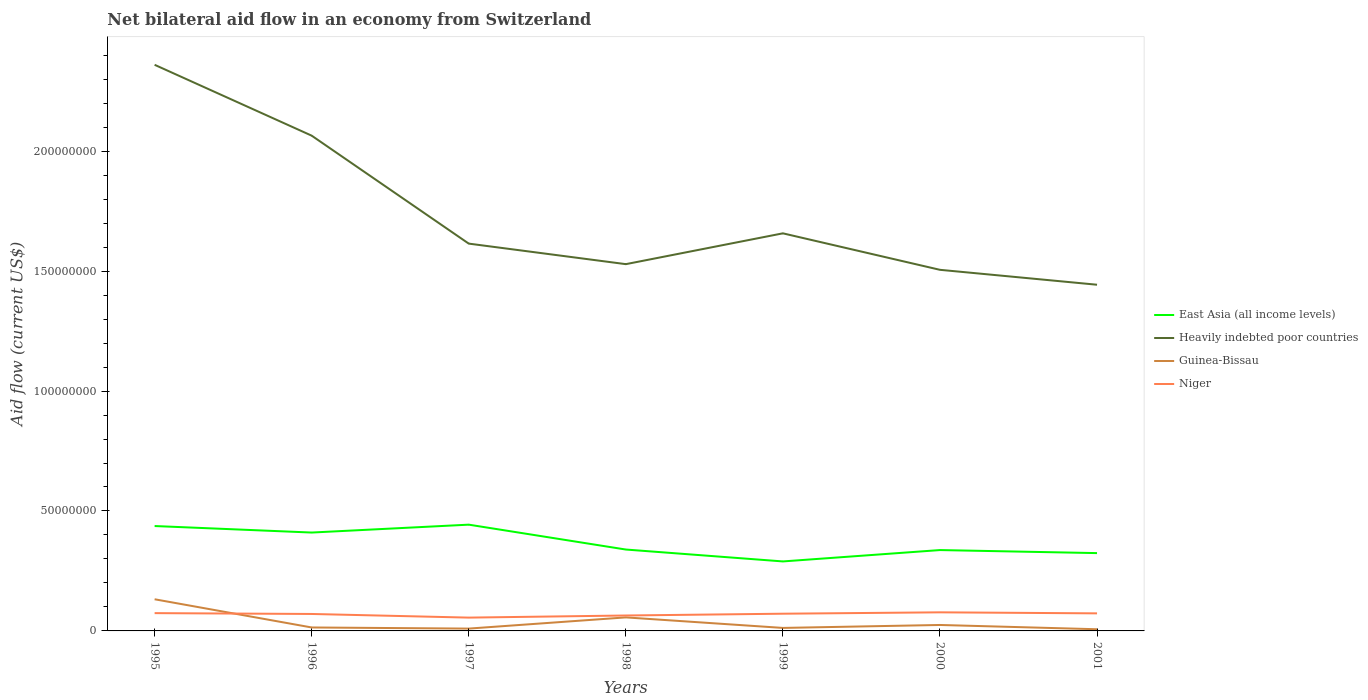Across all years, what is the maximum net bilateral aid flow in East Asia (all income levels)?
Provide a succinct answer. 2.90e+07. In which year was the net bilateral aid flow in Heavily indebted poor countries maximum?
Provide a short and direct response. 2001. What is the total net bilateral aid flow in East Asia (all income levels) in the graph?
Provide a short and direct response. -4.74e+06. What is the difference between the highest and the second highest net bilateral aid flow in Niger?
Offer a very short reply. 2.20e+06. Is the net bilateral aid flow in Heavily indebted poor countries strictly greater than the net bilateral aid flow in East Asia (all income levels) over the years?
Provide a succinct answer. No. How many lines are there?
Offer a very short reply. 4. How many years are there in the graph?
Give a very brief answer. 7. What is the difference between two consecutive major ticks on the Y-axis?
Your answer should be compact. 5.00e+07. Does the graph contain any zero values?
Make the answer very short. No. What is the title of the graph?
Make the answer very short. Net bilateral aid flow in an economy from Switzerland. What is the Aid flow (current US$) of East Asia (all income levels) in 1995?
Your response must be concise. 4.37e+07. What is the Aid flow (current US$) in Heavily indebted poor countries in 1995?
Your response must be concise. 2.36e+08. What is the Aid flow (current US$) of Guinea-Bissau in 1995?
Your answer should be very brief. 1.32e+07. What is the Aid flow (current US$) of Niger in 1995?
Offer a very short reply. 7.42e+06. What is the Aid flow (current US$) of East Asia (all income levels) in 1996?
Provide a short and direct response. 4.10e+07. What is the Aid flow (current US$) of Heavily indebted poor countries in 1996?
Your answer should be very brief. 2.06e+08. What is the Aid flow (current US$) of Guinea-Bissau in 1996?
Your response must be concise. 1.44e+06. What is the Aid flow (current US$) of Niger in 1996?
Provide a short and direct response. 7.07e+06. What is the Aid flow (current US$) of East Asia (all income levels) in 1997?
Give a very brief answer. 4.43e+07. What is the Aid flow (current US$) in Heavily indebted poor countries in 1997?
Keep it short and to the point. 1.61e+08. What is the Aid flow (current US$) of Guinea-Bissau in 1997?
Your response must be concise. 9.70e+05. What is the Aid flow (current US$) in Niger in 1997?
Offer a terse response. 5.55e+06. What is the Aid flow (current US$) in East Asia (all income levels) in 1998?
Give a very brief answer. 3.39e+07. What is the Aid flow (current US$) in Heavily indebted poor countries in 1998?
Your answer should be very brief. 1.53e+08. What is the Aid flow (current US$) of Guinea-Bissau in 1998?
Your answer should be compact. 5.64e+06. What is the Aid flow (current US$) in Niger in 1998?
Ensure brevity in your answer.  6.43e+06. What is the Aid flow (current US$) in East Asia (all income levels) in 1999?
Provide a short and direct response. 2.90e+07. What is the Aid flow (current US$) in Heavily indebted poor countries in 1999?
Make the answer very short. 1.66e+08. What is the Aid flow (current US$) of Guinea-Bissau in 1999?
Give a very brief answer. 1.25e+06. What is the Aid flow (current US$) of Niger in 1999?
Provide a short and direct response. 7.18e+06. What is the Aid flow (current US$) in East Asia (all income levels) in 2000?
Make the answer very short. 3.37e+07. What is the Aid flow (current US$) in Heavily indebted poor countries in 2000?
Make the answer very short. 1.51e+08. What is the Aid flow (current US$) in Guinea-Bissau in 2000?
Give a very brief answer. 2.48e+06. What is the Aid flow (current US$) in Niger in 2000?
Your answer should be very brief. 7.75e+06. What is the Aid flow (current US$) of East Asia (all income levels) in 2001?
Provide a succinct answer. 3.24e+07. What is the Aid flow (current US$) of Heavily indebted poor countries in 2001?
Your answer should be compact. 1.44e+08. What is the Aid flow (current US$) of Niger in 2001?
Your response must be concise. 7.32e+06. Across all years, what is the maximum Aid flow (current US$) of East Asia (all income levels)?
Your answer should be very brief. 4.43e+07. Across all years, what is the maximum Aid flow (current US$) of Heavily indebted poor countries?
Keep it short and to the point. 2.36e+08. Across all years, what is the maximum Aid flow (current US$) of Guinea-Bissau?
Ensure brevity in your answer.  1.32e+07. Across all years, what is the maximum Aid flow (current US$) in Niger?
Provide a succinct answer. 7.75e+06. Across all years, what is the minimum Aid flow (current US$) in East Asia (all income levels)?
Give a very brief answer. 2.90e+07. Across all years, what is the minimum Aid flow (current US$) in Heavily indebted poor countries?
Keep it short and to the point. 1.44e+08. Across all years, what is the minimum Aid flow (current US$) of Guinea-Bissau?
Your answer should be compact. 7.00e+05. Across all years, what is the minimum Aid flow (current US$) in Niger?
Ensure brevity in your answer.  5.55e+06. What is the total Aid flow (current US$) of East Asia (all income levels) in the graph?
Offer a terse response. 2.58e+08. What is the total Aid flow (current US$) in Heavily indebted poor countries in the graph?
Make the answer very short. 1.22e+09. What is the total Aid flow (current US$) of Guinea-Bissau in the graph?
Ensure brevity in your answer.  2.57e+07. What is the total Aid flow (current US$) in Niger in the graph?
Make the answer very short. 4.87e+07. What is the difference between the Aid flow (current US$) of East Asia (all income levels) in 1995 and that in 1996?
Provide a succinct answer. 2.72e+06. What is the difference between the Aid flow (current US$) in Heavily indebted poor countries in 1995 and that in 1996?
Your answer should be compact. 2.95e+07. What is the difference between the Aid flow (current US$) in Guinea-Bissau in 1995 and that in 1996?
Your answer should be compact. 1.18e+07. What is the difference between the Aid flow (current US$) in Niger in 1995 and that in 1996?
Make the answer very short. 3.50e+05. What is the difference between the Aid flow (current US$) in East Asia (all income levels) in 1995 and that in 1997?
Provide a succinct answer. -5.70e+05. What is the difference between the Aid flow (current US$) of Heavily indebted poor countries in 1995 and that in 1997?
Your answer should be compact. 7.46e+07. What is the difference between the Aid flow (current US$) in Guinea-Bissau in 1995 and that in 1997?
Offer a terse response. 1.22e+07. What is the difference between the Aid flow (current US$) of Niger in 1995 and that in 1997?
Ensure brevity in your answer.  1.87e+06. What is the difference between the Aid flow (current US$) of East Asia (all income levels) in 1995 and that in 1998?
Make the answer very short. 9.80e+06. What is the difference between the Aid flow (current US$) in Heavily indebted poor countries in 1995 and that in 1998?
Offer a terse response. 8.31e+07. What is the difference between the Aid flow (current US$) of Guinea-Bissau in 1995 and that in 1998?
Ensure brevity in your answer.  7.56e+06. What is the difference between the Aid flow (current US$) in Niger in 1995 and that in 1998?
Provide a succinct answer. 9.90e+05. What is the difference between the Aid flow (current US$) in East Asia (all income levels) in 1995 and that in 1999?
Your answer should be very brief. 1.48e+07. What is the difference between the Aid flow (current US$) of Heavily indebted poor countries in 1995 and that in 1999?
Give a very brief answer. 7.03e+07. What is the difference between the Aid flow (current US$) of Guinea-Bissau in 1995 and that in 1999?
Give a very brief answer. 1.20e+07. What is the difference between the Aid flow (current US$) in East Asia (all income levels) in 1995 and that in 2000?
Give a very brief answer. 1.00e+07. What is the difference between the Aid flow (current US$) in Heavily indebted poor countries in 1995 and that in 2000?
Offer a terse response. 8.55e+07. What is the difference between the Aid flow (current US$) in Guinea-Bissau in 1995 and that in 2000?
Offer a terse response. 1.07e+07. What is the difference between the Aid flow (current US$) in Niger in 1995 and that in 2000?
Your answer should be very brief. -3.30e+05. What is the difference between the Aid flow (current US$) in East Asia (all income levels) in 1995 and that in 2001?
Offer a very short reply. 1.13e+07. What is the difference between the Aid flow (current US$) of Heavily indebted poor countries in 1995 and that in 2001?
Your answer should be very brief. 9.17e+07. What is the difference between the Aid flow (current US$) of Guinea-Bissau in 1995 and that in 2001?
Give a very brief answer. 1.25e+07. What is the difference between the Aid flow (current US$) in Niger in 1995 and that in 2001?
Provide a short and direct response. 1.00e+05. What is the difference between the Aid flow (current US$) in East Asia (all income levels) in 1996 and that in 1997?
Your answer should be compact. -3.29e+06. What is the difference between the Aid flow (current US$) of Heavily indebted poor countries in 1996 and that in 1997?
Your answer should be compact. 4.50e+07. What is the difference between the Aid flow (current US$) of Niger in 1996 and that in 1997?
Your answer should be compact. 1.52e+06. What is the difference between the Aid flow (current US$) of East Asia (all income levels) in 1996 and that in 1998?
Provide a short and direct response. 7.08e+06. What is the difference between the Aid flow (current US$) of Heavily indebted poor countries in 1996 and that in 1998?
Give a very brief answer. 5.36e+07. What is the difference between the Aid flow (current US$) of Guinea-Bissau in 1996 and that in 1998?
Provide a short and direct response. -4.20e+06. What is the difference between the Aid flow (current US$) in Niger in 1996 and that in 1998?
Your response must be concise. 6.40e+05. What is the difference between the Aid flow (current US$) of East Asia (all income levels) in 1996 and that in 1999?
Offer a terse response. 1.20e+07. What is the difference between the Aid flow (current US$) in Heavily indebted poor countries in 1996 and that in 1999?
Offer a terse response. 4.07e+07. What is the difference between the Aid flow (current US$) of Guinea-Bissau in 1996 and that in 1999?
Your response must be concise. 1.90e+05. What is the difference between the Aid flow (current US$) of East Asia (all income levels) in 1996 and that in 2000?
Offer a very short reply. 7.30e+06. What is the difference between the Aid flow (current US$) in Heavily indebted poor countries in 1996 and that in 2000?
Make the answer very short. 5.59e+07. What is the difference between the Aid flow (current US$) of Guinea-Bissau in 1996 and that in 2000?
Keep it short and to the point. -1.04e+06. What is the difference between the Aid flow (current US$) of Niger in 1996 and that in 2000?
Ensure brevity in your answer.  -6.80e+05. What is the difference between the Aid flow (current US$) of East Asia (all income levels) in 1996 and that in 2001?
Offer a terse response. 8.57e+06. What is the difference between the Aid flow (current US$) in Heavily indebted poor countries in 1996 and that in 2001?
Your answer should be very brief. 6.22e+07. What is the difference between the Aid flow (current US$) of Guinea-Bissau in 1996 and that in 2001?
Your answer should be very brief. 7.40e+05. What is the difference between the Aid flow (current US$) in East Asia (all income levels) in 1997 and that in 1998?
Ensure brevity in your answer.  1.04e+07. What is the difference between the Aid flow (current US$) of Heavily indebted poor countries in 1997 and that in 1998?
Ensure brevity in your answer.  8.56e+06. What is the difference between the Aid flow (current US$) in Guinea-Bissau in 1997 and that in 1998?
Ensure brevity in your answer.  -4.67e+06. What is the difference between the Aid flow (current US$) of Niger in 1997 and that in 1998?
Provide a succinct answer. -8.80e+05. What is the difference between the Aid flow (current US$) of East Asia (all income levels) in 1997 and that in 1999?
Offer a very short reply. 1.53e+07. What is the difference between the Aid flow (current US$) of Heavily indebted poor countries in 1997 and that in 1999?
Give a very brief answer. -4.29e+06. What is the difference between the Aid flow (current US$) of Guinea-Bissau in 1997 and that in 1999?
Offer a very short reply. -2.80e+05. What is the difference between the Aid flow (current US$) of Niger in 1997 and that in 1999?
Your answer should be compact. -1.63e+06. What is the difference between the Aid flow (current US$) of East Asia (all income levels) in 1997 and that in 2000?
Provide a succinct answer. 1.06e+07. What is the difference between the Aid flow (current US$) of Heavily indebted poor countries in 1997 and that in 2000?
Your answer should be compact. 1.09e+07. What is the difference between the Aid flow (current US$) in Guinea-Bissau in 1997 and that in 2000?
Keep it short and to the point. -1.51e+06. What is the difference between the Aid flow (current US$) in Niger in 1997 and that in 2000?
Give a very brief answer. -2.20e+06. What is the difference between the Aid flow (current US$) in East Asia (all income levels) in 1997 and that in 2001?
Offer a terse response. 1.19e+07. What is the difference between the Aid flow (current US$) of Heavily indebted poor countries in 1997 and that in 2001?
Offer a terse response. 1.71e+07. What is the difference between the Aid flow (current US$) of Niger in 1997 and that in 2001?
Ensure brevity in your answer.  -1.77e+06. What is the difference between the Aid flow (current US$) of East Asia (all income levels) in 1998 and that in 1999?
Make the answer very short. 4.96e+06. What is the difference between the Aid flow (current US$) in Heavily indebted poor countries in 1998 and that in 1999?
Offer a very short reply. -1.28e+07. What is the difference between the Aid flow (current US$) of Guinea-Bissau in 1998 and that in 1999?
Offer a terse response. 4.39e+06. What is the difference between the Aid flow (current US$) of Niger in 1998 and that in 1999?
Keep it short and to the point. -7.50e+05. What is the difference between the Aid flow (current US$) of East Asia (all income levels) in 1998 and that in 2000?
Your response must be concise. 2.20e+05. What is the difference between the Aid flow (current US$) in Heavily indebted poor countries in 1998 and that in 2000?
Make the answer very short. 2.36e+06. What is the difference between the Aid flow (current US$) of Guinea-Bissau in 1998 and that in 2000?
Your answer should be compact. 3.16e+06. What is the difference between the Aid flow (current US$) in Niger in 1998 and that in 2000?
Provide a succinct answer. -1.32e+06. What is the difference between the Aid flow (current US$) in East Asia (all income levels) in 1998 and that in 2001?
Keep it short and to the point. 1.49e+06. What is the difference between the Aid flow (current US$) in Heavily indebted poor countries in 1998 and that in 2001?
Your answer should be compact. 8.58e+06. What is the difference between the Aid flow (current US$) of Guinea-Bissau in 1998 and that in 2001?
Make the answer very short. 4.94e+06. What is the difference between the Aid flow (current US$) in Niger in 1998 and that in 2001?
Offer a very short reply. -8.90e+05. What is the difference between the Aid flow (current US$) of East Asia (all income levels) in 1999 and that in 2000?
Provide a short and direct response. -4.74e+06. What is the difference between the Aid flow (current US$) in Heavily indebted poor countries in 1999 and that in 2000?
Your answer should be compact. 1.52e+07. What is the difference between the Aid flow (current US$) of Guinea-Bissau in 1999 and that in 2000?
Your answer should be compact. -1.23e+06. What is the difference between the Aid flow (current US$) in Niger in 1999 and that in 2000?
Make the answer very short. -5.70e+05. What is the difference between the Aid flow (current US$) of East Asia (all income levels) in 1999 and that in 2001?
Your answer should be compact. -3.47e+06. What is the difference between the Aid flow (current US$) in Heavily indebted poor countries in 1999 and that in 2001?
Give a very brief answer. 2.14e+07. What is the difference between the Aid flow (current US$) of Guinea-Bissau in 1999 and that in 2001?
Ensure brevity in your answer.  5.50e+05. What is the difference between the Aid flow (current US$) of Niger in 1999 and that in 2001?
Make the answer very short. -1.40e+05. What is the difference between the Aid flow (current US$) in East Asia (all income levels) in 2000 and that in 2001?
Offer a terse response. 1.27e+06. What is the difference between the Aid flow (current US$) of Heavily indebted poor countries in 2000 and that in 2001?
Keep it short and to the point. 6.22e+06. What is the difference between the Aid flow (current US$) of Guinea-Bissau in 2000 and that in 2001?
Provide a short and direct response. 1.78e+06. What is the difference between the Aid flow (current US$) of East Asia (all income levels) in 1995 and the Aid flow (current US$) of Heavily indebted poor countries in 1996?
Offer a terse response. -1.63e+08. What is the difference between the Aid flow (current US$) in East Asia (all income levels) in 1995 and the Aid flow (current US$) in Guinea-Bissau in 1996?
Offer a terse response. 4.23e+07. What is the difference between the Aid flow (current US$) in East Asia (all income levels) in 1995 and the Aid flow (current US$) in Niger in 1996?
Provide a short and direct response. 3.67e+07. What is the difference between the Aid flow (current US$) of Heavily indebted poor countries in 1995 and the Aid flow (current US$) of Guinea-Bissau in 1996?
Your answer should be very brief. 2.35e+08. What is the difference between the Aid flow (current US$) of Heavily indebted poor countries in 1995 and the Aid flow (current US$) of Niger in 1996?
Offer a very short reply. 2.29e+08. What is the difference between the Aid flow (current US$) in Guinea-Bissau in 1995 and the Aid flow (current US$) in Niger in 1996?
Ensure brevity in your answer.  6.13e+06. What is the difference between the Aid flow (current US$) in East Asia (all income levels) in 1995 and the Aid flow (current US$) in Heavily indebted poor countries in 1997?
Your response must be concise. -1.18e+08. What is the difference between the Aid flow (current US$) of East Asia (all income levels) in 1995 and the Aid flow (current US$) of Guinea-Bissau in 1997?
Offer a terse response. 4.28e+07. What is the difference between the Aid flow (current US$) in East Asia (all income levels) in 1995 and the Aid flow (current US$) in Niger in 1997?
Keep it short and to the point. 3.82e+07. What is the difference between the Aid flow (current US$) of Heavily indebted poor countries in 1995 and the Aid flow (current US$) of Guinea-Bissau in 1997?
Offer a terse response. 2.35e+08. What is the difference between the Aid flow (current US$) of Heavily indebted poor countries in 1995 and the Aid flow (current US$) of Niger in 1997?
Provide a succinct answer. 2.30e+08. What is the difference between the Aid flow (current US$) in Guinea-Bissau in 1995 and the Aid flow (current US$) in Niger in 1997?
Keep it short and to the point. 7.65e+06. What is the difference between the Aid flow (current US$) of East Asia (all income levels) in 1995 and the Aid flow (current US$) of Heavily indebted poor countries in 1998?
Keep it short and to the point. -1.09e+08. What is the difference between the Aid flow (current US$) in East Asia (all income levels) in 1995 and the Aid flow (current US$) in Guinea-Bissau in 1998?
Ensure brevity in your answer.  3.81e+07. What is the difference between the Aid flow (current US$) of East Asia (all income levels) in 1995 and the Aid flow (current US$) of Niger in 1998?
Give a very brief answer. 3.73e+07. What is the difference between the Aid flow (current US$) in Heavily indebted poor countries in 1995 and the Aid flow (current US$) in Guinea-Bissau in 1998?
Your response must be concise. 2.30e+08. What is the difference between the Aid flow (current US$) in Heavily indebted poor countries in 1995 and the Aid flow (current US$) in Niger in 1998?
Your response must be concise. 2.30e+08. What is the difference between the Aid flow (current US$) in Guinea-Bissau in 1995 and the Aid flow (current US$) in Niger in 1998?
Give a very brief answer. 6.77e+06. What is the difference between the Aid flow (current US$) of East Asia (all income levels) in 1995 and the Aid flow (current US$) of Heavily indebted poor countries in 1999?
Make the answer very short. -1.22e+08. What is the difference between the Aid flow (current US$) of East Asia (all income levels) in 1995 and the Aid flow (current US$) of Guinea-Bissau in 1999?
Keep it short and to the point. 4.25e+07. What is the difference between the Aid flow (current US$) of East Asia (all income levels) in 1995 and the Aid flow (current US$) of Niger in 1999?
Keep it short and to the point. 3.66e+07. What is the difference between the Aid flow (current US$) of Heavily indebted poor countries in 1995 and the Aid flow (current US$) of Guinea-Bissau in 1999?
Ensure brevity in your answer.  2.35e+08. What is the difference between the Aid flow (current US$) in Heavily indebted poor countries in 1995 and the Aid flow (current US$) in Niger in 1999?
Make the answer very short. 2.29e+08. What is the difference between the Aid flow (current US$) of Guinea-Bissau in 1995 and the Aid flow (current US$) of Niger in 1999?
Offer a terse response. 6.02e+06. What is the difference between the Aid flow (current US$) of East Asia (all income levels) in 1995 and the Aid flow (current US$) of Heavily indebted poor countries in 2000?
Your answer should be very brief. -1.07e+08. What is the difference between the Aid flow (current US$) of East Asia (all income levels) in 1995 and the Aid flow (current US$) of Guinea-Bissau in 2000?
Your answer should be very brief. 4.12e+07. What is the difference between the Aid flow (current US$) of East Asia (all income levels) in 1995 and the Aid flow (current US$) of Niger in 2000?
Keep it short and to the point. 3.60e+07. What is the difference between the Aid flow (current US$) in Heavily indebted poor countries in 1995 and the Aid flow (current US$) in Guinea-Bissau in 2000?
Your answer should be very brief. 2.34e+08. What is the difference between the Aid flow (current US$) in Heavily indebted poor countries in 1995 and the Aid flow (current US$) in Niger in 2000?
Provide a succinct answer. 2.28e+08. What is the difference between the Aid flow (current US$) of Guinea-Bissau in 1995 and the Aid flow (current US$) of Niger in 2000?
Ensure brevity in your answer.  5.45e+06. What is the difference between the Aid flow (current US$) of East Asia (all income levels) in 1995 and the Aid flow (current US$) of Heavily indebted poor countries in 2001?
Provide a succinct answer. -1.01e+08. What is the difference between the Aid flow (current US$) of East Asia (all income levels) in 1995 and the Aid flow (current US$) of Guinea-Bissau in 2001?
Ensure brevity in your answer.  4.30e+07. What is the difference between the Aid flow (current US$) in East Asia (all income levels) in 1995 and the Aid flow (current US$) in Niger in 2001?
Your answer should be very brief. 3.64e+07. What is the difference between the Aid flow (current US$) in Heavily indebted poor countries in 1995 and the Aid flow (current US$) in Guinea-Bissau in 2001?
Your answer should be very brief. 2.35e+08. What is the difference between the Aid flow (current US$) of Heavily indebted poor countries in 1995 and the Aid flow (current US$) of Niger in 2001?
Your answer should be very brief. 2.29e+08. What is the difference between the Aid flow (current US$) in Guinea-Bissau in 1995 and the Aid flow (current US$) in Niger in 2001?
Your answer should be compact. 5.88e+06. What is the difference between the Aid flow (current US$) of East Asia (all income levels) in 1996 and the Aid flow (current US$) of Heavily indebted poor countries in 1997?
Offer a very short reply. -1.20e+08. What is the difference between the Aid flow (current US$) in East Asia (all income levels) in 1996 and the Aid flow (current US$) in Guinea-Bissau in 1997?
Give a very brief answer. 4.00e+07. What is the difference between the Aid flow (current US$) in East Asia (all income levels) in 1996 and the Aid flow (current US$) in Niger in 1997?
Offer a terse response. 3.55e+07. What is the difference between the Aid flow (current US$) of Heavily indebted poor countries in 1996 and the Aid flow (current US$) of Guinea-Bissau in 1997?
Ensure brevity in your answer.  2.06e+08. What is the difference between the Aid flow (current US$) in Heavily indebted poor countries in 1996 and the Aid flow (current US$) in Niger in 1997?
Provide a succinct answer. 2.01e+08. What is the difference between the Aid flow (current US$) of Guinea-Bissau in 1996 and the Aid flow (current US$) of Niger in 1997?
Ensure brevity in your answer.  -4.11e+06. What is the difference between the Aid flow (current US$) in East Asia (all income levels) in 1996 and the Aid flow (current US$) in Heavily indebted poor countries in 1998?
Ensure brevity in your answer.  -1.12e+08. What is the difference between the Aid flow (current US$) in East Asia (all income levels) in 1996 and the Aid flow (current US$) in Guinea-Bissau in 1998?
Your answer should be compact. 3.54e+07. What is the difference between the Aid flow (current US$) in East Asia (all income levels) in 1996 and the Aid flow (current US$) in Niger in 1998?
Your answer should be very brief. 3.46e+07. What is the difference between the Aid flow (current US$) of Heavily indebted poor countries in 1996 and the Aid flow (current US$) of Guinea-Bissau in 1998?
Your answer should be very brief. 2.01e+08. What is the difference between the Aid flow (current US$) of Heavily indebted poor countries in 1996 and the Aid flow (current US$) of Niger in 1998?
Provide a succinct answer. 2.00e+08. What is the difference between the Aid flow (current US$) of Guinea-Bissau in 1996 and the Aid flow (current US$) of Niger in 1998?
Provide a succinct answer. -4.99e+06. What is the difference between the Aid flow (current US$) in East Asia (all income levels) in 1996 and the Aid flow (current US$) in Heavily indebted poor countries in 1999?
Ensure brevity in your answer.  -1.25e+08. What is the difference between the Aid flow (current US$) in East Asia (all income levels) in 1996 and the Aid flow (current US$) in Guinea-Bissau in 1999?
Provide a short and direct response. 3.98e+07. What is the difference between the Aid flow (current US$) in East Asia (all income levels) in 1996 and the Aid flow (current US$) in Niger in 1999?
Keep it short and to the point. 3.38e+07. What is the difference between the Aid flow (current US$) in Heavily indebted poor countries in 1996 and the Aid flow (current US$) in Guinea-Bissau in 1999?
Ensure brevity in your answer.  2.05e+08. What is the difference between the Aid flow (current US$) in Heavily indebted poor countries in 1996 and the Aid flow (current US$) in Niger in 1999?
Your answer should be compact. 1.99e+08. What is the difference between the Aid flow (current US$) in Guinea-Bissau in 1996 and the Aid flow (current US$) in Niger in 1999?
Your response must be concise. -5.74e+06. What is the difference between the Aid flow (current US$) of East Asia (all income levels) in 1996 and the Aid flow (current US$) of Heavily indebted poor countries in 2000?
Your answer should be compact. -1.10e+08. What is the difference between the Aid flow (current US$) of East Asia (all income levels) in 1996 and the Aid flow (current US$) of Guinea-Bissau in 2000?
Provide a succinct answer. 3.85e+07. What is the difference between the Aid flow (current US$) of East Asia (all income levels) in 1996 and the Aid flow (current US$) of Niger in 2000?
Provide a succinct answer. 3.33e+07. What is the difference between the Aid flow (current US$) of Heavily indebted poor countries in 1996 and the Aid flow (current US$) of Guinea-Bissau in 2000?
Your response must be concise. 2.04e+08. What is the difference between the Aid flow (current US$) of Heavily indebted poor countries in 1996 and the Aid flow (current US$) of Niger in 2000?
Keep it short and to the point. 1.99e+08. What is the difference between the Aid flow (current US$) in Guinea-Bissau in 1996 and the Aid flow (current US$) in Niger in 2000?
Your answer should be very brief. -6.31e+06. What is the difference between the Aid flow (current US$) in East Asia (all income levels) in 1996 and the Aid flow (current US$) in Heavily indebted poor countries in 2001?
Give a very brief answer. -1.03e+08. What is the difference between the Aid flow (current US$) in East Asia (all income levels) in 1996 and the Aid flow (current US$) in Guinea-Bissau in 2001?
Keep it short and to the point. 4.03e+07. What is the difference between the Aid flow (current US$) in East Asia (all income levels) in 1996 and the Aid flow (current US$) in Niger in 2001?
Ensure brevity in your answer.  3.37e+07. What is the difference between the Aid flow (current US$) of Heavily indebted poor countries in 1996 and the Aid flow (current US$) of Guinea-Bissau in 2001?
Keep it short and to the point. 2.06e+08. What is the difference between the Aid flow (current US$) of Heavily indebted poor countries in 1996 and the Aid flow (current US$) of Niger in 2001?
Keep it short and to the point. 1.99e+08. What is the difference between the Aid flow (current US$) in Guinea-Bissau in 1996 and the Aid flow (current US$) in Niger in 2001?
Your answer should be compact. -5.88e+06. What is the difference between the Aid flow (current US$) of East Asia (all income levels) in 1997 and the Aid flow (current US$) of Heavily indebted poor countries in 1998?
Make the answer very short. -1.09e+08. What is the difference between the Aid flow (current US$) in East Asia (all income levels) in 1997 and the Aid flow (current US$) in Guinea-Bissau in 1998?
Your response must be concise. 3.87e+07. What is the difference between the Aid flow (current US$) of East Asia (all income levels) in 1997 and the Aid flow (current US$) of Niger in 1998?
Offer a very short reply. 3.79e+07. What is the difference between the Aid flow (current US$) of Heavily indebted poor countries in 1997 and the Aid flow (current US$) of Guinea-Bissau in 1998?
Offer a very short reply. 1.56e+08. What is the difference between the Aid flow (current US$) in Heavily indebted poor countries in 1997 and the Aid flow (current US$) in Niger in 1998?
Your answer should be very brief. 1.55e+08. What is the difference between the Aid flow (current US$) of Guinea-Bissau in 1997 and the Aid flow (current US$) of Niger in 1998?
Ensure brevity in your answer.  -5.46e+06. What is the difference between the Aid flow (current US$) in East Asia (all income levels) in 1997 and the Aid flow (current US$) in Heavily indebted poor countries in 1999?
Offer a very short reply. -1.21e+08. What is the difference between the Aid flow (current US$) of East Asia (all income levels) in 1997 and the Aid flow (current US$) of Guinea-Bissau in 1999?
Make the answer very short. 4.30e+07. What is the difference between the Aid flow (current US$) in East Asia (all income levels) in 1997 and the Aid flow (current US$) in Niger in 1999?
Your answer should be very brief. 3.71e+07. What is the difference between the Aid flow (current US$) of Heavily indebted poor countries in 1997 and the Aid flow (current US$) of Guinea-Bissau in 1999?
Your answer should be very brief. 1.60e+08. What is the difference between the Aid flow (current US$) in Heavily indebted poor countries in 1997 and the Aid flow (current US$) in Niger in 1999?
Provide a short and direct response. 1.54e+08. What is the difference between the Aid flow (current US$) in Guinea-Bissau in 1997 and the Aid flow (current US$) in Niger in 1999?
Offer a terse response. -6.21e+06. What is the difference between the Aid flow (current US$) of East Asia (all income levels) in 1997 and the Aid flow (current US$) of Heavily indebted poor countries in 2000?
Your answer should be very brief. -1.06e+08. What is the difference between the Aid flow (current US$) of East Asia (all income levels) in 1997 and the Aid flow (current US$) of Guinea-Bissau in 2000?
Make the answer very short. 4.18e+07. What is the difference between the Aid flow (current US$) of East Asia (all income levels) in 1997 and the Aid flow (current US$) of Niger in 2000?
Keep it short and to the point. 3.66e+07. What is the difference between the Aid flow (current US$) in Heavily indebted poor countries in 1997 and the Aid flow (current US$) in Guinea-Bissau in 2000?
Give a very brief answer. 1.59e+08. What is the difference between the Aid flow (current US$) in Heavily indebted poor countries in 1997 and the Aid flow (current US$) in Niger in 2000?
Offer a terse response. 1.54e+08. What is the difference between the Aid flow (current US$) in Guinea-Bissau in 1997 and the Aid flow (current US$) in Niger in 2000?
Offer a very short reply. -6.78e+06. What is the difference between the Aid flow (current US$) of East Asia (all income levels) in 1997 and the Aid flow (current US$) of Heavily indebted poor countries in 2001?
Offer a very short reply. -1.00e+08. What is the difference between the Aid flow (current US$) of East Asia (all income levels) in 1997 and the Aid flow (current US$) of Guinea-Bissau in 2001?
Provide a succinct answer. 4.36e+07. What is the difference between the Aid flow (current US$) of East Asia (all income levels) in 1997 and the Aid flow (current US$) of Niger in 2001?
Your answer should be very brief. 3.70e+07. What is the difference between the Aid flow (current US$) in Heavily indebted poor countries in 1997 and the Aid flow (current US$) in Guinea-Bissau in 2001?
Your response must be concise. 1.61e+08. What is the difference between the Aid flow (current US$) in Heavily indebted poor countries in 1997 and the Aid flow (current US$) in Niger in 2001?
Offer a terse response. 1.54e+08. What is the difference between the Aid flow (current US$) of Guinea-Bissau in 1997 and the Aid flow (current US$) of Niger in 2001?
Keep it short and to the point. -6.35e+06. What is the difference between the Aid flow (current US$) of East Asia (all income levels) in 1998 and the Aid flow (current US$) of Heavily indebted poor countries in 1999?
Your answer should be compact. -1.32e+08. What is the difference between the Aid flow (current US$) in East Asia (all income levels) in 1998 and the Aid flow (current US$) in Guinea-Bissau in 1999?
Make the answer very short. 3.27e+07. What is the difference between the Aid flow (current US$) of East Asia (all income levels) in 1998 and the Aid flow (current US$) of Niger in 1999?
Ensure brevity in your answer.  2.68e+07. What is the difference between the Aid flow (current US$) in Heavily indebted poor countries in 1998 and the Aid flow (current US$) in Guinea-Bissau in 1999?
Provide a succinct answer. 1.52e+08. What is the difference between the Aid flow (current US$) of Heavily indebted poor countries in 1998 and the Aid flow (current US$) of Niger in 1999?
Offer a terse response. 1.46e+08. What is the difference between the Aid flow (current US$) in Guinea-Bissau in 1998 and the Aid flow (current US$) in Niger in 1999?
Provide a succinct answer. -1.54e+06. What is the difference between the Aid flow (current US$) of East Asia (all income levels) in 1998 and the Aid flow (current US$) of Heavily indebted poor countries in 2000?
Provide a short and direct response. -1.17e+08. What is the difference between the Aid flow (current US$) of East Asia (all income levels) in 1998 and the Aid flow (current US$) of Guinea-Bissau in 2000?
Offer a very short reply. 3.14e+07. What is the difference between the Aid flow (current US$) of East Asia (all income levels) in 1998 and the Aid flow (current US$) of Niger in 2000?
Ensure brevity in your answer.  2.62e+07. What is the difference between the Aid flow (current US$) of Heavily indebted poor countries in 1998 and the Aid flow (current US$) of Guinea-Bissau in 2000?
Your response must be concise. 1.50e+08. What is the difference between the Aid flow (current US$) of Heavily indebted poor countries in 1998 and the Aid flow (current US$) of Niger in 2000?
Your response must be concise. 1.45e+08. What is the difference between the Aid flow (current US$) of Guinea-Bissau in 1998 and the Aid flow (current US$) of Niger in 2000?
Offer a very short reply. -2.11e+06. What is the difference between the Aid flow (current US$) in East Asia (all income levels) in 1998 and the Aid flow (current US$) in Heavily indebted poor countries in 2001?
Offer a terse response. -1.10e+08. What is the difference between the Aid flow (current US$) of East Asia (all income levels) in 1998 and the Aid flow (current US$) of Guinea-Bissau in 2001?
Your response must be concise. 3.32e+07. What is the difference between the Aid flow (current US$) in East Asia (all income levels) in 1998 and the Aid flow (current US$) in Niger in 2001?
Your answer should be very brief. 2.66e+07. What is the difference between the Aid flow (current US$) of Heavily indebted poor countries in 1998 and the Aid flow (current US$) of Guinea-Bissau in 2001?
Keep it short and to the point. 1.52e+08. What is the difference between the Aid flow (current US$) of Heavily indebted poor countries in 1998 and the Aid flow (current US$) of Niger in 2001?
Make the answer very short. 1.46e+08. What is the difference between the Aid flow (current US$) of Guinea-Bissau in 1998 and the Aid flow (current US$) of Niger in 2001?
Ensure brevity in your answer.  -1.68e+06. What is the difference between the Aid flow (current US$) of East Asia (all income levels) in 1999 and the Aid flow (current US$) of Heavily indebted poor countries in 2000?
Ensure brevity in your answer.  -1.22e+08. What is the difference between the Aid flow (current US$) in East Asia (all income levels) in 1999 and the Aid flow (current US$) in Guinea-Bissau in 2000?
Offer a very short reply. 2.65e+07. What is the difference between the Aid flow (current US$) of East Asia (all income levels) in 1999 and the Aid flow (current US$) of Niger in 2000?
Your answer should be very brief. 2.12e+07. What is the difference between the Aid flow (current US$) in Heavily indebted poor countries in 1999 and the Aid flow (current US$) in Guinea-Bissau in 2000?
Ensure brevity in your answer.  1.63e+08. What is the difference between the Aid flow (current US$) of Heavily indebted poor countries in 1999 and the Aid flow (current US$) of Niger in 2000?
Give a very brief answer. 1.58e+08. What is the difference between the Aid flow (current US$) in Guinea-Bissau in 1999 and the Aid flow (current US$) in Niger in 2000?
Ensure brevity in your answer.  -6.50e+06. What is the difference between the Aid flow (current US$) in East Asia (all income levels) in 1999 and the Aid flow (current US$) in Heavily indebted poor countries in 2001?
Give a very brief answer. -1.15e+08. What is the difference between the Aid flow (current US$) of East Asia (all income levels) in 1999 and the Aid flow (current US$) of Guinea-Bissau in 2001?
Give a very brief answer. 2.83e+07. What is the difference between the Aid flow (current US$) in East Asia (all income levels) in 1999 and the Aid flow (current US$) in Niger in 2001?
Give a very brief answer. 2.16e+07. What is the difference between the Aid flow (current US$) of Heavily indebted poor countries in 1999 and the Aid flow (current US$) of Guinea-Bissau in 2001?
Offer a terse response. 1.65e+08. What is the difference between the Aid flow (current US$) in Heavily indebted poor countries in 1999 and the Aid flow (current US$) in Niger in 2001?
Your answer should be very brief. 1.58e+08. What is the difference between the Aid flow (current US$) in Guinea-Bissau in 1999 and the Aid flow (current US$) in Niger in 2001?
Your answer should be compact. -6.07e+06. What is the difference between the Aid flow (current US$) of East Asia (all income levels) in 2000 and the Aid flow (current US$) of Heavily indebted poor countries in 2001?
Ensure brevity in your answer.  -1.11e+08. What is the difference between the Aid flow (current US$) of East Asia (all income levels) in 2000 and the Aid flow (current US$) of Guinea-Bissau in 2001?
Make the answer very short. 3.30e+07. What is the difference between the Aid flow (current US$) in East Asia (all income levels) in 2000 and the Aid flow (current US$) in Niger in 2001?
Make the answer very short. 2.64e+07. What is the difference between the Aid flow (current US$) of Heavily indebted poor countries in 2000 and the Aid flow (current US$) of Guinea-Bissau in 2001?
Keep it short and to the point. 1.50e+08. What is the difference between the Aid flow (current US$) of Heavily indebted poor countries in 2000 and the Aid flow (current US$) of Niger in 2001?
Keep it short and to the point. 1.43e+08. What is the difference between the Aid flow (current US$) of Guinea-Bissau in 2000 and the Aid flow (current US$) of Niger in 2001?
Provide a short and direct response. -4.84e+06. What is the average Aid flow (current US$) in East Asia (all income levels) per year?
Ensure brevity in your answer.  3.69e+07. What is the average Aid flow (current US$) of Heavily indebted poor countries per year?
Provide a succinct answer. 1.74e+08. What is the average Aid flow (current US$) of Guinea-Bissau per year?
Provide a succinct answer. 3.67e+06. What is the average Aid flow (current US$) of Niger per year?
Provide a succinct answer. 6.96e+06. In the year 1995, what is the difference between the Aid flow (current US$) in East Asia (all income levels) and Aid flow (current US$) in Heavily indebted poor countries?
Provide a succinct answer. -1.92e+08. In the year 1995, what is the difference between the Aid flow (current US$) of East Asia (all income levels) and Aid flow (current US$) of Guinea-Bissau?
Provide a short and direct response. 3.05e+07. In the year 1995, what is the difference between the Aid flow (current US$) of East Asia (all income levels) and Aid flow (current US$) of Niger?
Make the answer very short. 3.63e+07. In the year 1995, what is the difference between the Aid flow (current US$) in Heavily indebted poor countries and Aid flow (current US$) in Guinea-Bissau?
Your response must be concise. 2.23e+08. In the year 1995, what is the difference between the Aid flow (current US$) of Heavily indebted poor countries and Aid flow (current US$) of Niger?
Ensure brevity in your answer.  2.29e+08. In the year 1995, what is the difference between the Aid flow (current US$) of Guinea-Bissau and Aid flow (current US$) of Niger?
Offer a very short reply. 5.78e+06. In the year 1996, what is the difference between the Aid flow (current US$) in East Asia (all income levels) and Aid flow (current US$) in Heavily indebted poor countries?
Your response must be concise. -1.65e+08. In the year 1996, what is the difference between the Aid flow (current US$) in East Asia (all income levels) and Aid flow (current US$) in Guinea-Bissau?
Offer a very short reply. 3.96e+07. In the year 1996, what is the difference between the Aid flow (current US$) in East Asia (all income levels) and Aid flow (current US$) in Niger?
Give a very brief answer. 3.39e+07. In the year 1996, what is the difference between the Aid flow (current US$) of Heavily indebted poor countries and Aid flow (current US$) of Guinea-Bissau?
Keep it short and to the point. 2.05e+08. In the year 1996, what is the difference between the Aid flow (current US$) in Heavily indebted poor countries and Aid flow (current US$) in Niger?
Offer a terse response. 1.99e+08. In the year 1996, what is the difference between the Aid flow (current US$) of Guinea-Bissau and Aid flow (current US$) of Niger?
Your response must be concise. -5.63e+06. In the year 1997, what is the difference between the Aid flow (current US$) in East Asia (all income levels) and Aid flow (current US$) in Heavily indebted poor countries?
Your answer should be compact. -1.17e+08. In the year 1997, what is the difference between the Aid flow (current US$) of East Asia (all income levels) and Aid flow (current US$) of Guinea-Bissau?
Your response must be concise. 4.33e+07. In the year 1997, what is the difference between the Aid flow (current US$) of East Asia (all income levels) and Aid flow (current US$) of Niger?
Your response must be concise. 3.88e+07. In the year 1997, what is the difference between the Aid flow (current US$) in Heavily indebted poor countries and Aid flow (current US$) in Guinea-Bissau?
Give a very brief answer. 1.60e+08. In the year 1997, what is the difference between the Aid flow (current US$) in Heavily indebted poor countries and Aid flow (current US$) in Niger?
Your response must be concise. 1.56e+08. In the year 1997, what is the difference between the Aid flow (current US$) of Guinea-Bissau and Aid flow (current US$) of Niger?
Provide a succinct answer. -4.58e+06. In the year 1998, what is the difference between the Aid flow (current US$) in East Asia (all income levels) and Aid flow (current US$) in Heavily indebted poor countries?
Provide a short and direct response. -1.19e+08. In the year 1998, what is the difference between the Aid flow (current US$) of East Asia (all income levels) and Aid flow (current US$) of Guinea-Bissau?
Provide a short and direct response. 2.83e+07. In the year 1998, what is the difference between the Aid flow (current US$) of East Asia (all income levels) and Aid flow (current US$) of Niger?
Give a very brief answer. 2.75e+07. In the year 1998, what is the difference between the Aid flow (current US$) of Heavily indebted poor countries and Aid flow (current US$) of Guinea-Bissau?
Offer a terse response. 1.47e+08. In the year 1998, what is the difference between the Aid flow (current US$) of Heavily indebted poor countries and Aid flow (current US$) of Niger?
Give a very brief answer. 1.46e+08. In the year 1998, what is the difference between the Aid flow (current US$) in Guinea-Bissau and Aid flow (current US$) in Niger?
Your response must be concise. -7.90e+05. In the year 1999, what is the difference between the Aid flow (current US$) in East Asia (all income levels) and Aid flow (current US$) in Heavily indebted poor countries?
Make the answer very short. -1.37e+08. In the year 1999, what is the difference between the Aid flow (current US$) in East Asia (all income levels) and Aid flow (current US$) in Guinea-Bissau?
Give a very brief answer. 2.77e+07. In the year 1999, what is the difference between the Aid flow (current US$) in East Asia (all income levels) and Aid flow (current US$) in Niger?
Offer a very short reply. 2.18e+07. In the year 1999, what is the difference between the Aid flow (current US$) in Heavily indebted poor countries and Aid flow (current US$) in Guinea-Bissau?
Your answer should be very brief. 1.64e+08. In the year 1999, what is the difference between the Aid flow (current US$) in Heavily indebted poor countries and Aid flow (current US$) in Niger?
Offer a very short reply. 1.59e+08. In the year 1999, what is the difference between the Aid flow (current US$) in Guinea-Bissau and Aid flow (current US$) in Niger?
Give a very brief answer. -5.93e+06. In the year 2000, what is the difference between the Aid flow (current US$) in East Asia (all income levels) and Aid flow (current US$) in Heavily indebted poor countries?
Your answer should be compact. -1.17e+08. In the year 2000, what is the difference between the Aid flow (current US$) of East Asia (all income levels) and Aid flow (current US$) of Guinea-Bissau?
Provide a short and direct response. 3.12e+07. In the year 2000, what is the difference between the Aid flow (current US$) in East Asia (all income levels) and Aid flow (current US$) in Niger?
Provide a short and direct response. 2.60e+07. In the year 2000, what is the difference between the Aid flow (current US$) in Heavily indebted poor countries and Aid flow (current US$) in Guinea-Bissau?
Your answer should be very brief. 1.48e+08. In the year 2000, what is the difference between the Aid flow (current US$) in Heavily indebted poor countries and Aid flow (current US$) in Niger?
Provide a short and direct response. 1.43e+08. In the year 2000, what is the difference between the Aid flow (current US$) in Guinea-Bissau and Aid flow (current US$) in Niger?
Provide a succinct answer. -5.27e+06. In the year 2001, what is the difference between the Aid flow (current US$) in East Asia (all income levels) and Aid flow (current US$) in Heavily indebted poor countries?
Your response must be concise. -1.12e+08. In the year 2001, what is the difference between the Aid flow (current US$) of East Asia (all income levels) and Aid flow (current US$) of Guinea-Bissau?
Give a very brief answer. 3.17e+07. In the year 2001, what is the difference between the Aid flow (current US$) in East Asia (all income levels) and Aid flow (current US$) in Niger?
Ensure brevity in your answer.  2.51e+07. In the year 2001, what is the difference between the Aid flow (current US$) of Heavily indebted poor countries and Aid flow (current US$) of Guinea-Bissau?
Ensure brevity in your answer.  1.44e+08. In the year 2001, what is the difference between the Aid flow (current US$) of Heavily indebted poor countries and Aid flow (current US$) of Niger?
Give a very brief answer. 1.37e+08. In the year 2001, what is the difference between the Aid flow (current US$) in Guinea-Bissau and Aid flow (current US$) in Niger?
Give a very brief answer. -6.62e+06. What is the ratio of the Aid flow (current US$) of East Asia (all income levels) in 1995 to that in 1996?
Provide a short and direct response. 1.07. What is the ratio of the Aid flow (current US$) of Heavily indebted poor countries in 1995 to that in 1996?
Keep it short and to the point. 1.14. What is the ratio of the Aid flow (current US$) of Guinea-Bissau in 1995 to that in 1996?
Provide a short and direct response. 9.17. What is the ratio of the Aid flow (current US$) of Niger in 1995 to that in 1996?
Provide a short and direct response. 1.05. What is the ratio of the Aid flow (current US$) in East Asia (all income levels) in 1995 to that in 1997?
Provide a succinct answer. 0.99. What is the ratio of the Aid flow (current US$) of Heavily indebted poor countries in 1995 to that in 1997?
Keep it short and to the point. 1.46. What is the ratio of the Aid flow (current US$) in Guinea-Bissau in 1995 to that in 1997?
Your answer should be very brief. 13.61. What is the ratio of the Aid flow (current US$) in Niger in 1995 to that in 1997?
Give a very brief answer. 1.34. What is the ratio of the Aid flow (current US$) in East Asia (all income levels) in 1995 to that in 1998?
Provide a short and direct response. 1.29. What is the ratio of the Aid flow (current US$) in Heavily indebted poor countries in 1995 to that in 1998?
Your response must be concise. 1.54. What is the ratio of the Aid flow (current US$) in Guinea-Bissau in 1995 to that in 1998?
Keep it short and to the point. 2.34. What is the ratio of the Aid flow (current US$) in Niger in 1995 to that in 1998?
Keep it short and to the point. 1.15. What is the ratio of the Aid flow (current US$) in East Asia (all income levels) in 1995 to that in 1999?
Provide a short and direct response. 1.51. What is the ratio of the Aid flow (current US$) of Heavily indebted poor countries in 1995 to that in 1999?
Provide a short and direct response. 1.42. What is the ratio of the Aid flow (current US$) in Guinea-Bissau in 1995 to that in 1999?
Your answer should be compact. 10.56. What is the ratio of the Aid flow (current US$) of Niger in 1995 to that in 1999?
Offer a very short reply. 1.03. What is the ratio of the Aid flow (current US$) of East Asia (all income levels) in 1995 to that in 2000?
Your response must be concise. 1.3. What is the ratio of the Aid flow (current US$) in Heavily indebted poor countries in 1995 to that in 2000?
Your answer should be very brief. 1.57. What is the ratio of the Aid flow (current US$) of Guinea-Bissau in 1995 to that in 2000?
Make the answer very short. 5.32. What is the ratio of the Aid flow (current US$) of Niger in 1995 to that in 2000?
Your response must be concise. 0.96. What is the ratio of the Aid flow (current US$) of East Asia (all income levels) in 1995 to that in 2001?
Make the answer very short. 1.35. What is the ratio of the Aid flow (current US$) of Heavily indebted poor countries in 1995 to that in 2001?
Offer a terse response. 1.64. What is the ratio of the Aid flow (current US$) of Guinea-Bissau in 1995 to that in 2001?
Keep it short and to the point. 18.86. What is the ratio of the Aid flow (current US$) in Niger in 1995 to that in 2001?
Provide a short and direct response. 1.01. What is the ratio of the Aid flow (current US$) in East Asia (all income levels) in 1996 to that in 1997?
Offer a very short reply. 0.93. What is the ratio of the Aid flow (current US$) of Heavily indebted poor countries in 1996 to that in 1997?
Provide a succinct answer. 1.28. What is the ratio of the Aid flow (current US$) of Guinea-Bissau in 1996 to that in 1997?
Give a very brief answer. 1.48. What is the ratio of the Aid flow (current US$) of Niger in 1996 to that in 1997?
Offer a very short reply. 1.27. What is the ratio of the Aid flow (current US$) in East Asia (all income levels) in 1996 to that in 1998?
Your answer should be compact. 1.21. What is the ratio of the Aid flow (current US$) of Heavily indebted poor countries in 1996 to that in 1998?
Keep it short and to the point. 1.35. What is the ratio of the Aid flow (current US$) in Guinea-Bissau in 1996 to that in 1998?
Provide a succinct answer. 0.26. What is the ratio of the Aid flow (current US$) in Niger in 1996 to that in 1998?
Offer a terse response. 1.1. What is the ratio of the Aid flow (current US$) of East Asia (all income levels) in 1996 to that in 1999?
Offer a very short reply. 1.42. What is the ratio of the Aid flow (current US$) of Heavily indebted poor countries in 1996 to that in 1999?
Provide a succinct answer. 1.25. What is the ratio of the Aid flow (current US$) in Guinea-Bissau in 1996 to that in 1999?
Make the answer very short. 1.15. What is the ratio of the Aid flow (current US$) in Niger in 1996 to that in 1999?
Offer a very short reply. 0.98. What is the ratio of the Aid flow (current US$) in East Asia (all income levels) in 1996 to that in 2000?
Make the answer very short. 1.22. What is the ratio of the Aid flow (current US$) of Heavily indebted poor countries in 1996 to that in 2000?
Offer a terse response. 1.37. What is the ratio of the Aid flow (current US$) of Guinea-Bissau in 1996 to that in 2000?
Provide a short and direct response. 0.58. What is the ratio of the Aid flow (current US$) of Niger in 1996 to that in 2000?
Ensure brevity in your answer.  0.91. What is the ratio of the Aid flow (current US$) in East Asia (all income levels) in 1996 to that in 2001?
Your response must be concise. 1.26. What is the ratio of the Aid flow (current US$) of Heavily indebted poor countries in 1996 to that in 2001?
Provide a succinct answer. 1.43. What is the ratio of the Aid flow (current US$) of Guinea-Bissau in 1996 to that in 2001?
Your response must be concise. 2.06. What is the ratio of the Aid flow (current US$) in Niger in 1996 to that in 2001?
Your answer should be very brief. 0.97. What is the ratio of the Aid flow (current US$) in East Asia (all income levels) in 1997 to that in 1998?
Your response must be concise. 1.31. What is the ratio of the Aid flow (current US$) in Heavily indebted poor countries in 1997 to that in 1998?
Offer a very short reply. 1.06. What is the ratio of the Aid flow (current US$) of Guinea-Bissau in 1997 to that in 1998?
Provide a succinct answer. 0.17. What is the ratio of the Aid flow (current US$) in Niger in 1997 to that in 1998?
Keep it short and to the point. 0.86. What is the ratio of the Aid flow (current US$) of East Asia (all income levels) in 1997 to that in 1999?
Ensure brevity in your answer.  1.53. What is the ratio of the Aid flow (current US$) of Heavily indebted poor countries in 1997 to that in 1999?
Offer a terse response. 0.97. What is the ratio of the Aid flow (current US$) of Guinea-Bissau in 1997 to that in 1999?
Ensure brevity in your answer.  0.78. What is the ratio of the Aid flow (current US$) in Niger in 1997 to that in 1999?
Give a very brief answer. 0.77. What is the ratio of the Aid flow (current US$) of East Asia (all income levels) in 1997 to that in 2000?
Your answer should be compact. 1.31. What is the ratio of the Aid flow (current US$) in Heavily indebted poor countries in 1997 to that in 2000?
Ensure brevity in your answer.  1.07. What is the ratio of the Aid flow (current US$) in Guinea-Bissau in 1997 to that in 2000?
Your response must be concise. 0.39. What is the ratio of the Aid flow (current US$) in Niger in 1997 to that in 2000?
Your answer should be compact. 0.72. What is the ratio of the Aid flow (current US$) of East Asia (all income levels) in 1997 to that in 2001?
Make the answer very short. 1.37. What is the ratio of the Aid flow (current US$) of Heavily indebted poor countries in 1997 to that in 2001?
Your answer should be very brief. 1.12. What is the ratio of the Aid flow (current US$) of Guinea-Bissau in 1997 to that in 2001?
Make the answer very short. 1.39. What is the ratio of the Aid flow (current US$) in Niger in 1997 to that in 2001?
Keep it short and to the point. 0.76. What is the ratio of the Aid flow (current US$) of East Asia (all income levels) in 1998 to that in 1999?
Your answer should be very brief. 1.17. What is the ratio of the Aid flow (current US$) of Heavily indebted poor countries in 1998 to that in 1999?
Give a very brief answer. 0.92. What is the ratio of the Aid flow (current US$) in Guinea-Bissau in 1998 to that in 1999?
Provide a succinct answer. 4.51. What is the ratio of the Aid flow (current US$) in Niger in 1998 to that in 1999?
Your answer should be compact. 0.9. What is the ratio of the Aid flow (current US$) in East Asia (all income levels) in 1998 to that in 2000?
Your response must be concise. 1.01. What is the ratio of the Aid flow (current US$) in Heavily indebted poor countries in 1998 to that in 2000?
Make the answer very short. 1.02. What is the ratio of the Aid flow (current US$) of Guinea-Bissau in 1998 to that in 2000?
Provide a succinct answer. 2.27. What is the ratio of the Aid flow (current US$) in Niger in 1998 to that in 2000?
Make the answer very short. 0.83. What is the ratio of the Aid flow (current US$) in East Asia (all income levels) in 1998 to that in 2001?
Provide a short and direct response. 1.05. What is the ratio of the Aid flow (current US$) in Heavily indebted poor countries in 1998 to that in 2001?
Your response must be concise. 1.06. What is the ratio of the Aid flow (current US$) in Guinea-Bissau in 1998 to that in 2001?
Your response must be concise. 8.06. What is the ratio of the Aid flow (current US$) of Niger in 1998 to that in 2001?
Keep it short and to the point. 0.88. What is the ratio of the Aid flow (current US$) in East Asia (all income levels) in 1999 to that in 2000?
Give a very brief answer. 0.86. What is the ratio of the Aid flow (current US$) in Heavily indebted poor countries in 1999 to that in 2000?
Your answer should be very brief. 1.1. What is the ratio of the Aid flow (current US$) of Guinea-Bissau in 1999 to that in 2000?
Offer a very short reply. 0.5. What is the ratio of the Aid flow (current US$) of Niger in 1999 to that in 2000?
Provide a succinct answer. 0.93. What is the ratio of the Aid flow (current US$) of East Asia (all income levels) in 1999 to that in 2001?
Give a very brief answer. 0.89. What is the ratio of the Aid flow (current US$) of Heavily indebted poor countries in 1999 to that in 2001?
Your answer should be compact. 1.15. What is the ratio of the Aid flow (current US$) of Guinea-Bissau in 1999 to that in 2001?
Offer a very short reply. 1.79. What is the ratio of the Aid flow (current US$) in Niger in 1999 to that in 2001?
Offer a very short reply. 0.98. What is the ratio of the Aid flow (current US$) in East Asia (all income levels) in 2000 to that in 2001?
Your response must be concise. 1.04. What is the ratio of the Aid flow (current US$) of Heavily indebted poor countries in 2000 to that in 2001?
Offer a terse response. 1.04. What is the ratio of the Aid flow (current US$) in Guinea-Bissau in 2000 to that in 2001?
Make the answer very short. 3.54. What is the ratio of the Aid flow (current US$) in Niger in 2000 to that in 2001?
Provide a succinct answer. 1.06. What is the difference between the highest and the second highest Aid flow (current US$) of East Asia (all income levels)?
Offer a terse response. 5.70e+05. What is the difference between the highest and the second highest Aid flow (current US$) of Heavily indebted poor countries?
Give a very brief answer. 2.95e+07. What is the difference between the highest and the second highest Aid flow (current US$) in Guinea-Bissau?
Ensure brevity in your answer.  7.56e+06. What is the difference between the highest and the second highest Aid flow (current US$) of Niger?
Give a very brief answer. 3.30e+05. What is the difference between the highest and the lowest Aid flow (current US$) in East Asia (all income levels)?
Your answer should be compact. 1.53e+07. What is the difference between the highest and the lowest Aid flow (current US$) of Heavily indebted poor countries?
Provide a succinct answer. 9.17e+07. What is the difference between the highest and the lowest Aid flow (current US$) in Guinea-Bissau?
Make the answer very short. 1.25e+07. What is the difference between the highest and the lowest Aid flow (current US$) of Niger?
Provide a short and direct response. 2.20e+06. 